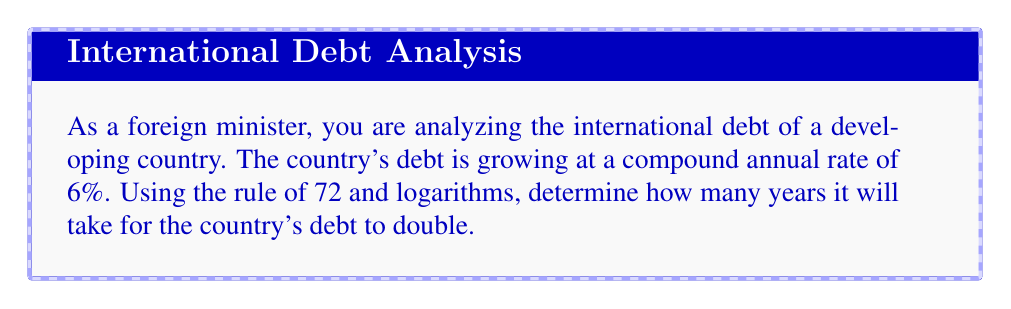Solve this math problem. To solve this problem, we'll use the rule of 72 and logarithms. The rule of 72 is an approximation that relates the doubling time of an exponentially growing quantity to its growth rate.

1) The rule of 72 states that:

   $$ 72 \approx r \times t $$

   Where $r$ is the annual growth rate (in percent) and $t$ is the time to double.

2) We can rearrange this to solve for $t$:

   $$ t \approx \frac{72}{r} $$

3) In this case, $r = 6\%$. Substituting this in:

   $$ t \approx \frac{72}{6} = 12 $$

4) To get a more precise answer, we can use the exact formula for doubling time:

   $$ t = \frac{\ln(2)}{\ln(1 + \frac{r}{100})} $$

5) Substituting $r = 6$:

   $$ t = \frac{\ln(2)}{\ln(1 + \frac{6}{100})} = \frac{\ln(2)}{\ln(1.06)} $$

6) Using a calculator or computer:

   $$ t \approx 11.8957 \text{ years} $$

This more precise calculation confirms that our approximation using the rule of 72 was quite accurate.
Answer: It will take approximately 11.90 years for the country's debt to double. 